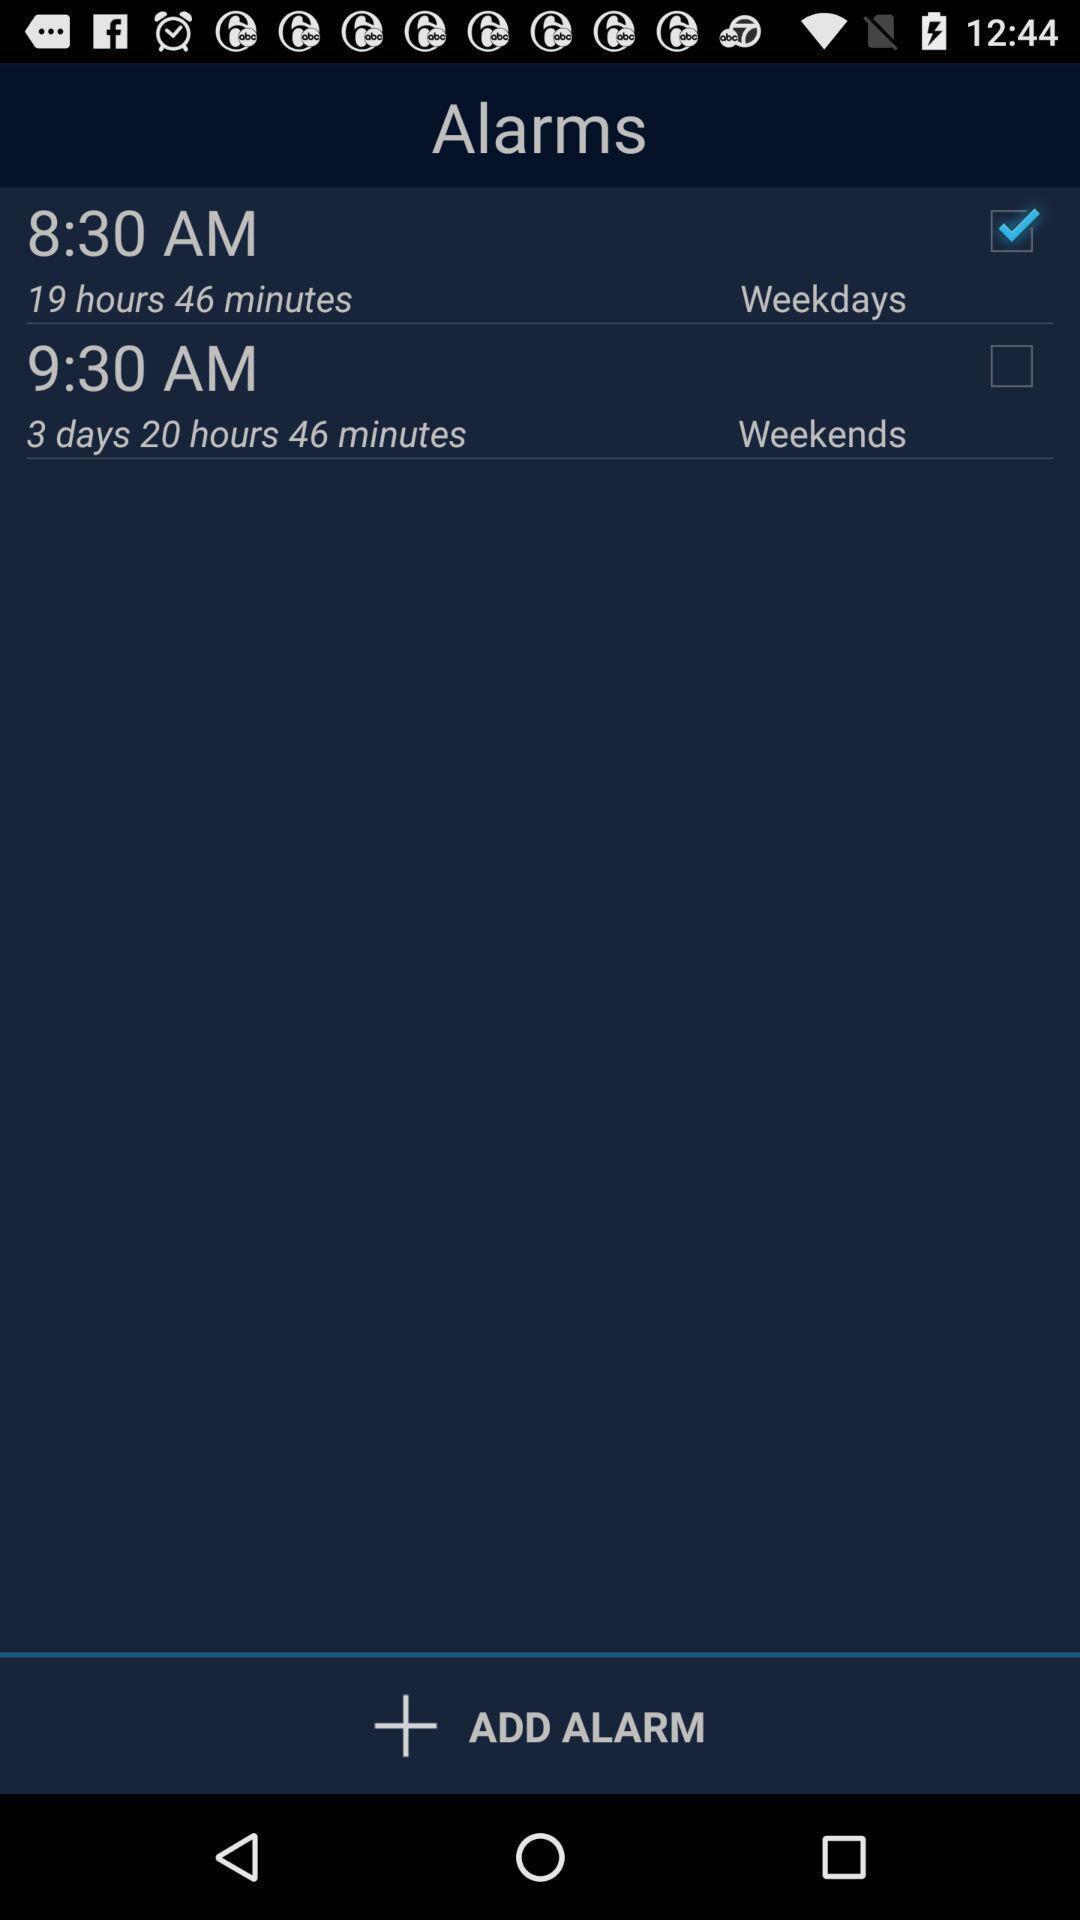Please provide a description for this image. Two alarms with weekday settings are displaying. 